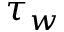Convert formula to latex. <formula><loc_0><loc_0><loc_500><loc_500>\tau _ { w }</formula> 